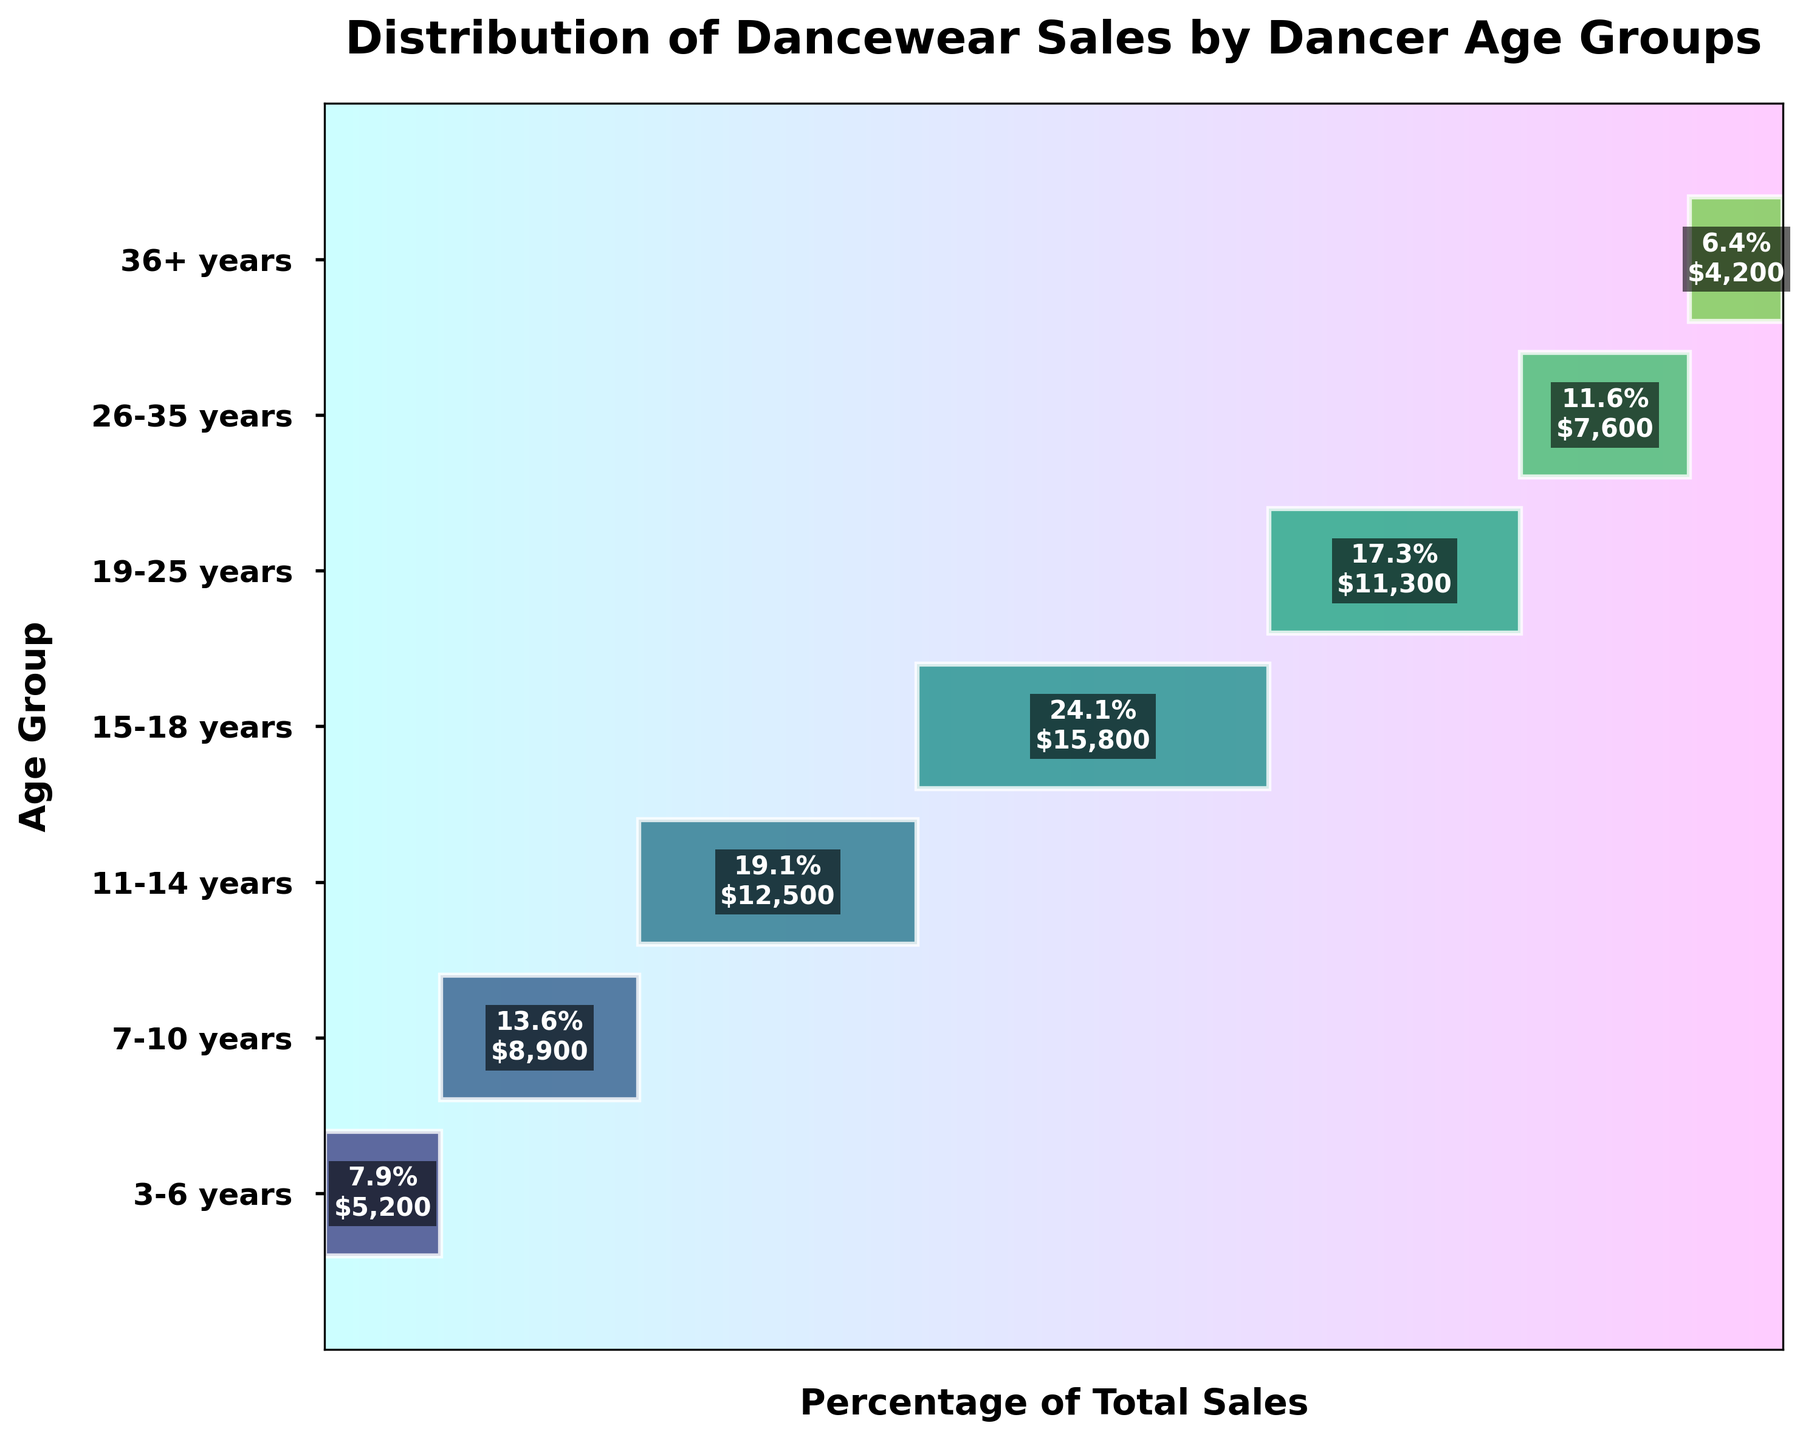Which age group has the highest sales volume? The funnel chart's largest segment, representing the group with the highest sales, is clearly labeled. The 15-18 years age group has the highest sales volume.
Answer: 15-18 years What is the title of the funnel chart? The title of the funnel chart is displayed prominently at the top of the chart. The title reads "Distribution of Dancewear Sales by Dancer Age Groups."
Answer: Distribution of Dancewear Sales by Dancer Age Groups What percentage of total sales comes from the 11-14 years age group? By looking at the width of the funnel segment for the 11-14 years age group, which has the percentage labeled within it, we can see the corresponding percentage. The 11-14 years age group represents 21.5% of the total sales.
Answer: 21.5% Arrange the age groups in descending order of their sales volume. To determine the order, we look at the funnel segments from the widest to the narrowest. The order is 15-18 years, 11-14 years, 19-25 years, 7-10 years, 26-35 years, 3-6 years, and 36+ years.
Answer: 15-18 years, 11-14 years, 19-25 years, 7-10 years, 26-35 years, 3-6 years, 36+ years How does the sales volume for the 26-35 years group compare to the 19-25 years group? We compare the funnel segment widths, where sales volume for each group is labeled. The 26-35 years group's segment has a lower width and percentage compared to the 19-25 years group (13.1% vs. 19.5%).
Answer: Less What is the combined percentage of sales from the 3-6 years and 36+ years age groups? The funnel chart indicates the percentages for each group. Adding these two percentages, 3-6 years (9.0%) and 36+ years (7.3%), gives a combined percentage. The total is 9.0% + 7.3% = 16.3%.
Answer: 16.3% Which age group has the lowest sales volume and what is that volume? The smallest segment of the funnel chart represents the group with the lowest sales volume. The 36+ years age group has the lowest sales volume of 4200 units.
Answer: 36+ years, 4200 units How much larger, in both percentage and volume, are the 7-10 years age group's sales compared to the 3-6 years age group's? We look at the percentage and volume labels for both groups: 7-10 years (15.4%, 8900 units) and 3-6 years (9.0%, 5200 units). The difference in percentages is 15.4% - 9.0% = 6.4%, and in volume, it's 8900 - 5200 = 3700 units.
Answer: 6.4%, 3700 units What is the cumulative percentage of sales from the two oldest age groups? The funnel chart shows individual percentages for each group. By adding the percentages for the 26-35 years (13.1%) and 36+ years (7.3%) age groups, we get 13.1% + 7.3% = 20.4%.
Answer: 20.4% 